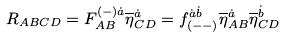<formula> <loc_0><loc_0><loc_500><loc_500>R _ { A B C D } = F ^ { ( - ) \dot { a } } _ { A B } \overline { \eta } ^ { \dot { a } } _ { C D } = f ^ { \dot { a } \dot { b } } _ { ( - - ) } \overline { \eta } ^ { \dot { a } } _ { A B } \overline { \eta } ^ { \dot { b } } _ { C D }</formula> 